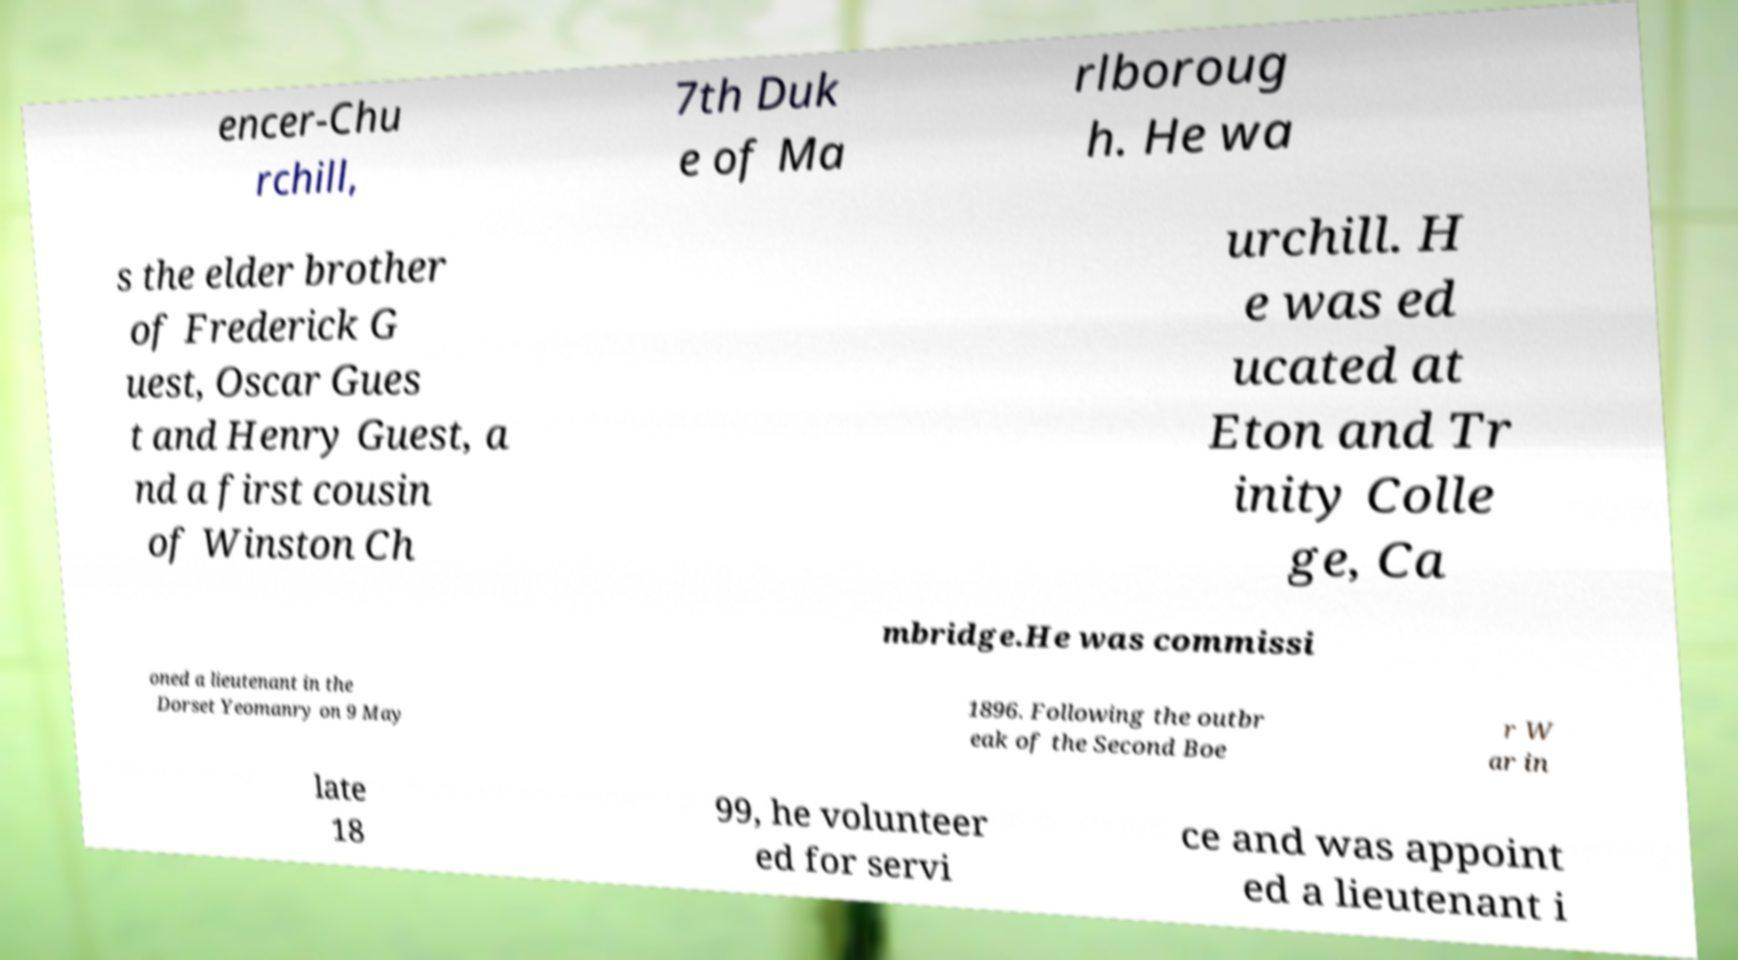Could you extract and type out the text from this image? encer-Chu rchill, 7th Duk e of Ma rlboroug h. He wa s the elder brother of Frederick G uest, Oscar Gues t and Henry Guest, a nd a first cousin of Winston Ch urchill. H e was ed ucated at Eton and Tr inity Colle ge, Ca mbridge.He was commissi oned a lieutenant in the Dorset Yeomanry on 9 May 1896. Following the outbr eak of the Second Boe r W ar in late 18 99, he volunteer ed for servi ce and was appoint ed a lieutenant i 